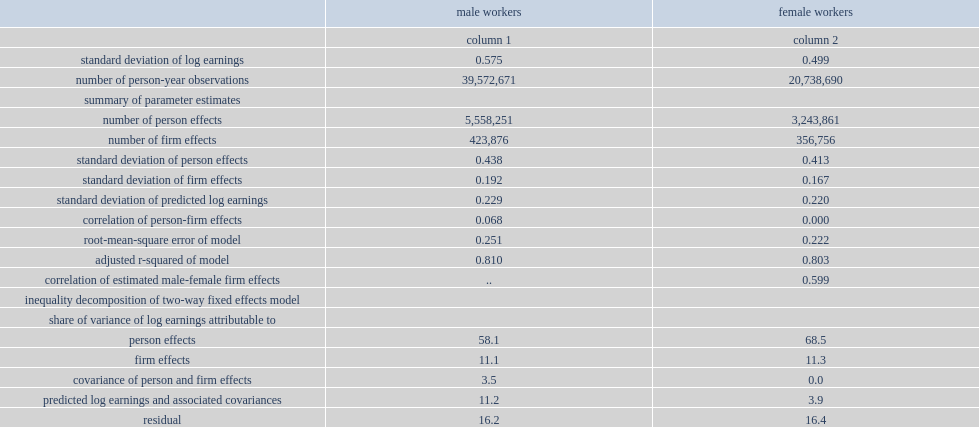The most important contributor to total variance was person effects, what was the percentage of the variance of earnings for male workers? 58.1. The most important contributor to total variance was person effects, what was the percentage of the variance of earnings for female workers? 68.5. The lower contribution of person effects for male workers was compensated by a higher contribution of the variance of predicted earnings based on observable characteristics and associated covariances, what was the percentage of the variance for male workers? 11.2. The lower contribution of person effects for male workers was compensated by a higher contribution of the variance of predicted earnings based on observable characteristics and associated covariances, what was the percentage of the variance for female workers? 3.9. What was the percentage of firm fixed effects for male workers? 11.1. What was the percentage of firm fixed effects for female workers? 11.3. What was the covariance between person and firm effect for male workers? 3.5. What was the covariance between person and firm effect for female workers? 0.0. 